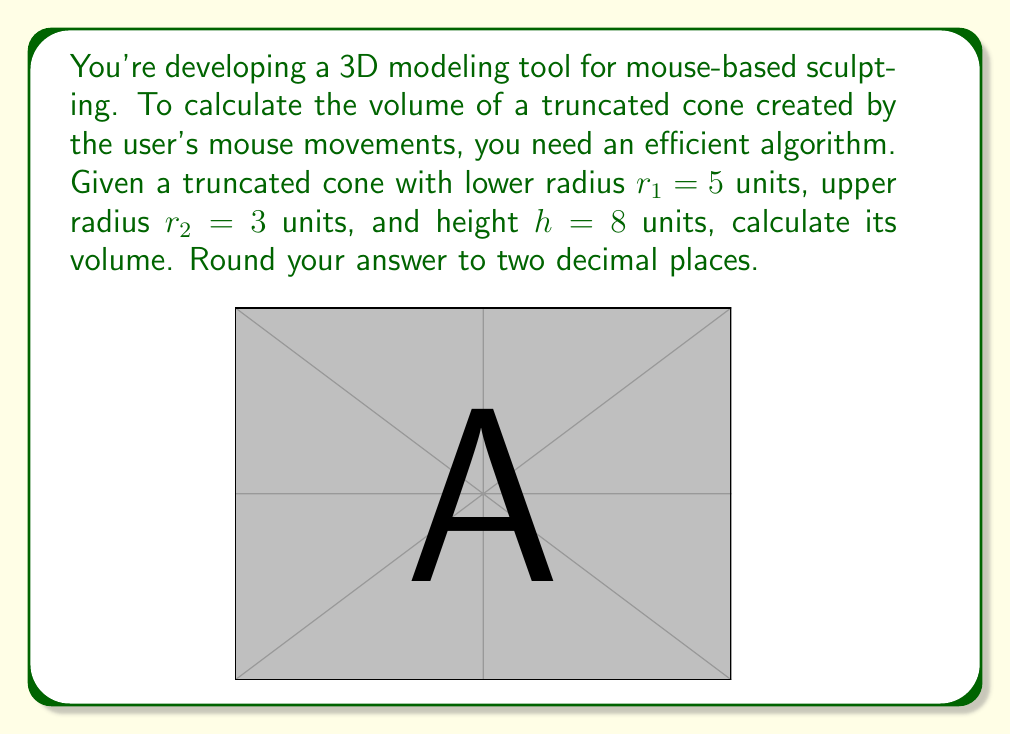What is the answer to this math problem? To calculate the volume of a truncated cone, we'll use the formula:

$$V = \frac{1}{3}\pi h(r_1^2 + r_2^2 + r_1r_2)$$

Where:
$V$ = volume
$h$ = height
$r_1$ = radius of the lower base
$r_2$ = radius of the upper base

Let's substitute the given values:

$h = 8$
$r_1 = 5$
$r_2 = 3$

Now, let's calculate step by step:

1) First, calculate $r_1^2$, $r_2^2$, and $r_1r_2$:
   $r_1^2 = 5^2 = 25$
   $r_2^2 = 3^2 = 9$
   $r_1r_2 = 5 * 3 = 15$

2) Add these values:
   $r_1^2 + r_2^2 + r_1r_2 = 25 + 9 + 15 = 49$

3) Multiply by $h$:
   $h(r_1^2 + r_2^2 + r_1r_2) = 8 * 49 = 392$

4) Multiply by $\frac{1}{3}\pi$:
   $V = \frac{1}{3}\pi * 392 \approx 410.12$

5) Round to two decimal places:
   $V \approx 410.12$ cubic units
Answer: $410.12$ cubic units 